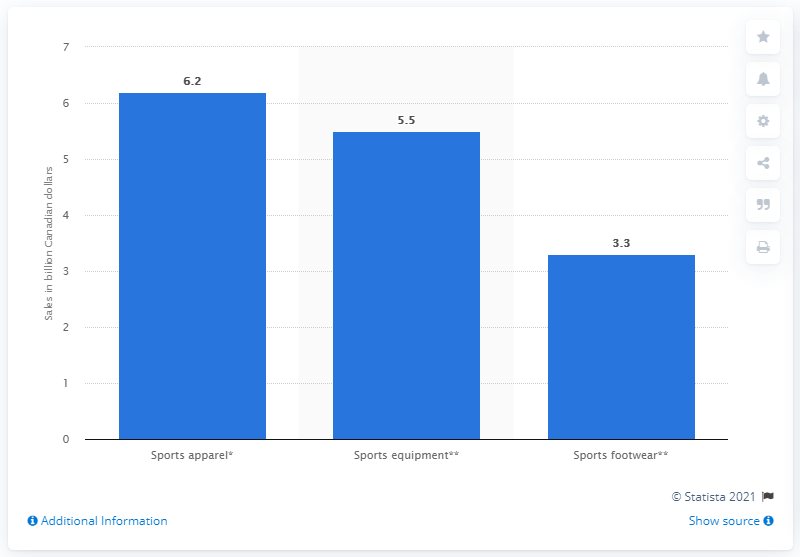Indicate a few pertinent items in this graphic. According to the marketing data for the year ending in March 2018, sports apparel generated a total of CAD 6.2 billion in Canada. In March 2018, the sports footwear market in Canada generated CAD 3.3 billion in revenue. 